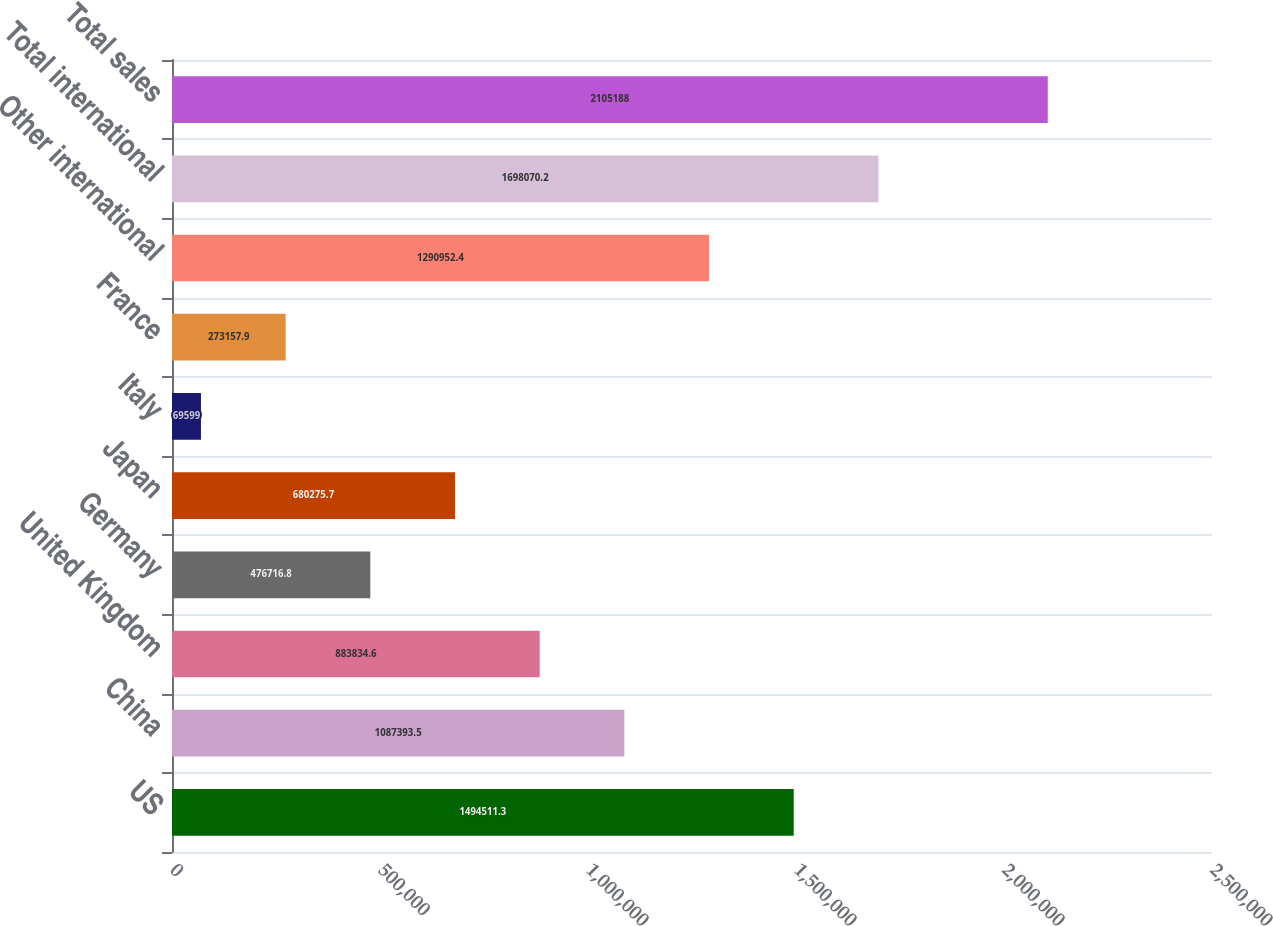Convert chart to OTSL. <chart><loc_0><loc_0><loc_500><loc_500><bar_chart><fcel>US<fcel>China<fcel>United Kingdom<fcel>Germany<fcel>Japan<fcel>Italy<fcel>France<fcel>Other international<fcel>Total international<fcel>Total sales<nl><fcel>1.49451e+06<fcel>1.08739e+06<fcel>883835<fcel>476717<fcel>680276<fcel>69599<fcel>273158<fcel>1.29095e+06<fcel>1.69807e+06<fcel>2.10519e+06<nl></chart> 